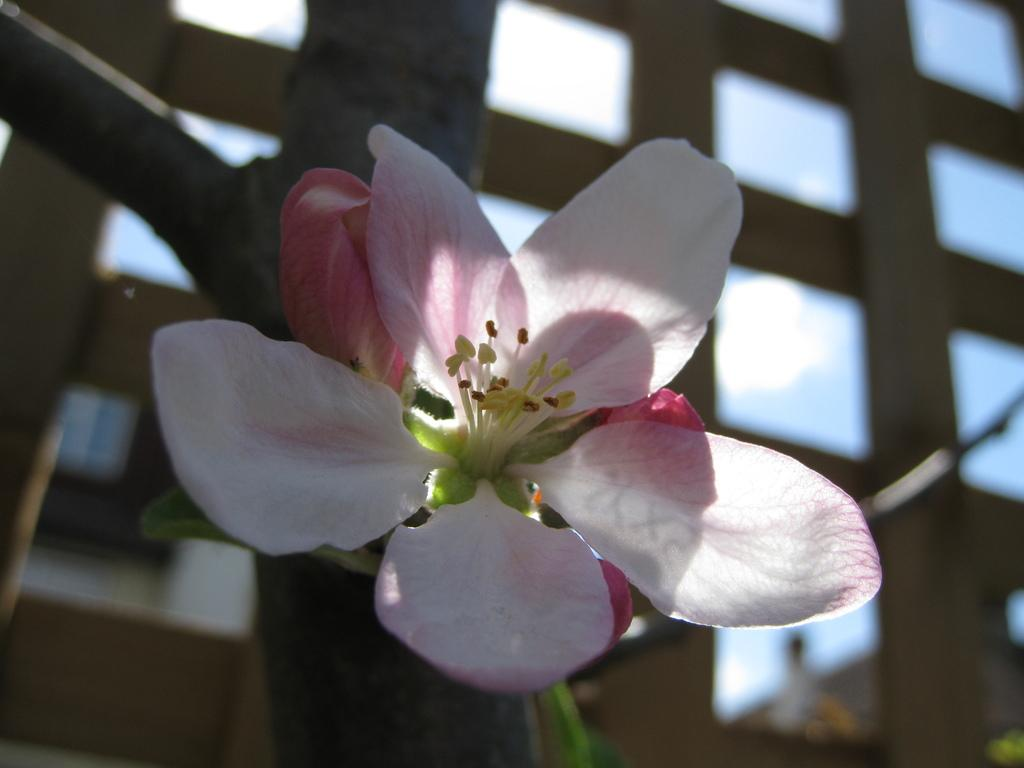What is the main subject of the image? There is a flower in the image. Can you describe the colors of the flower? The flower has white and pink colors. What can be seen in the background of the image? There are buildings and the sky visible in the background of the image. What type of chin can be seen on the flower in the image? There is no chin present on the flower in the image, as flowers do not have chins. 